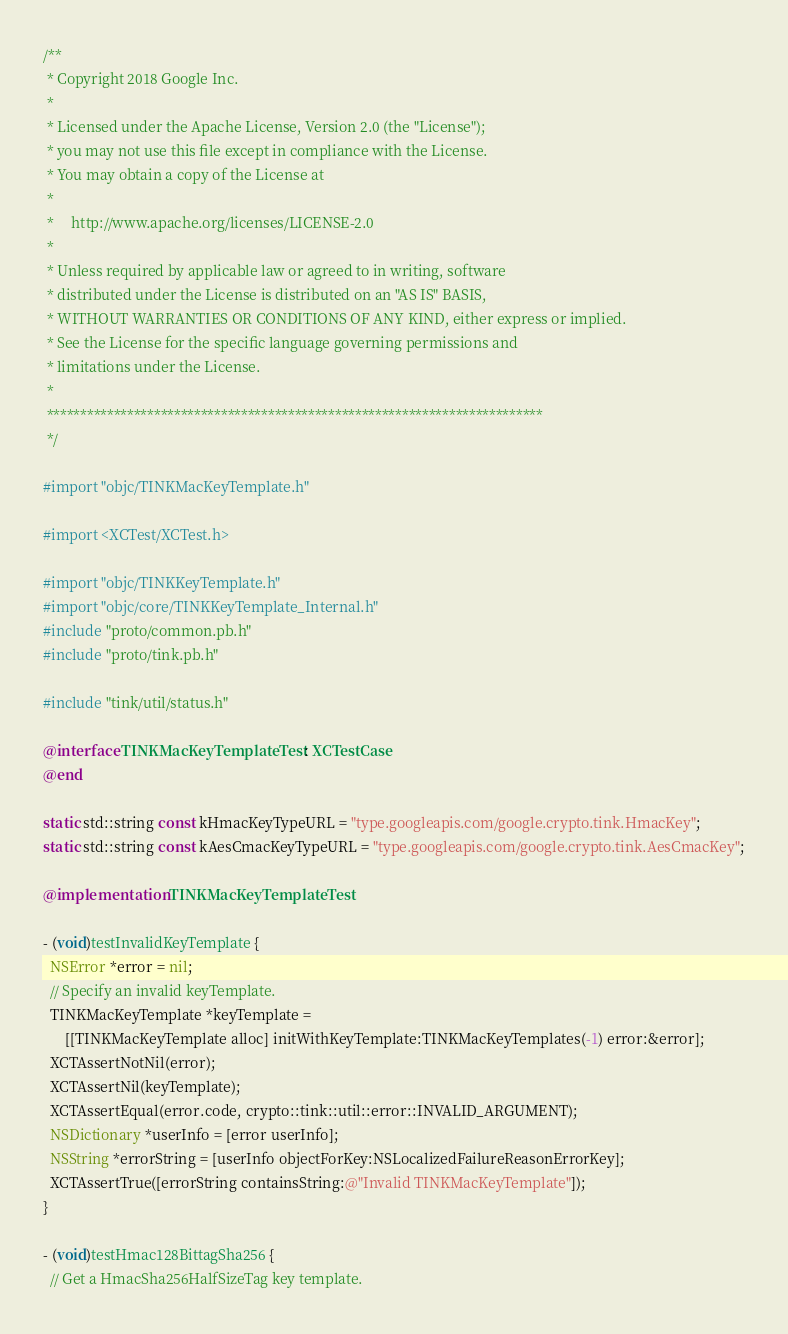Convert code to text. <code><loc_0><loc_0><loc_500><loc_500><_ObjectiveC_>/**
 * Copyright 2018 Google Inc.
 *
 * Licensed under the Apache License, Version 2.0 (the "License");
 * you may not use this file except in compliance with the License.
 * You may obtain a copy of the License at
 *
 *     http://www.apache.org/licenses/LICENSE-2.0
 *
 * Unless required by applicable law or agreed to in writing, software
 * distributed under the License is distributed on an "AS IS" BASIS,
 * WITHOUT WARRANTIES OR CONDITIONS OF ANY KIND, either express or implied.
 * See the License for the specific language governing permissions and
 * limitations under the License.
 *
 **************************************************************************
 */

#import "objc/TINKMacKeyTemplate.h"

#import <XCTest/XCTest.h>

#import "objc/TINKKeyTemplate.h"
#import "objc/core/TINKKeyTemplate_Internal.h"
#include "proto/common.pb.h"
#include "proto/tink.pb.h"

#include "tink/util/status.h"

@interface TINKMacKeyTemplateTest : XCTestCase
@end

static std::string const kHmacKeyTypeURL = "type.googleapis.com/google.crypto.tink.HmacKey";
static std::string const kAesCmacKeyTypeURL = "type.googleapis.com/google.crypto.tink.AesCmacKey";

@implementation TINKMacKeyTemplateTest

- (void)testInvalidKeyTemplate {
  NSError *error = nil;
  // Specify an invalid keyTemplate.
  TINKMacKeyTemplate *keyTemplate =
      [[TINKMacKeyTemplate alloc] initWithKeyTemplate:TINKMacKeyTemplates(-1) error:&error];
  XCTAssertNotNil(error);
  XCTAssertNil(keyTemplate);
  XCTAssertEqual(error.code, crypto::tink::util::error::INVALID_ARGUMENT);
  NSDictionary *userInfo = [error userInfo];
  NSString *errorString = [userInfo objectForKey:NSLocalizedFailureReasonErrorKey];
  XCTAssertTrue([errorString containsString:@"Invalid TINKMacKeyTemplate"]);
}

- (void)testHmac128BittagSha256 {
  // Get a HmacSha256HalfSizeTag key template.</code> 